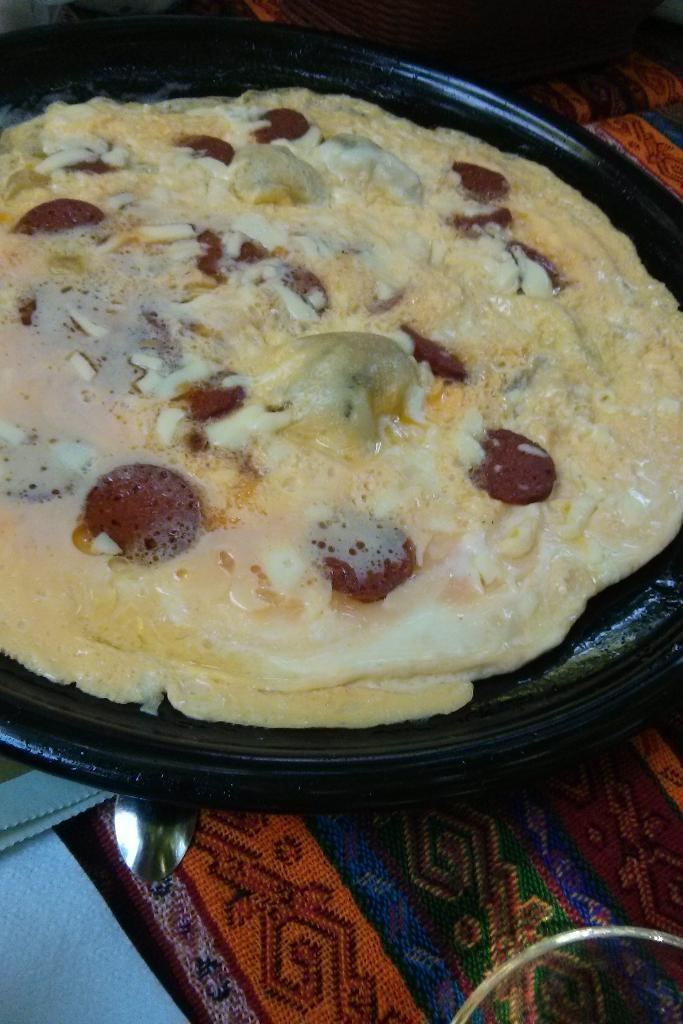What is on the plate in the image? There is food on a plate in the image. What direction is the church facing in the image? There is no church present in the image; it only features food on a plate. 